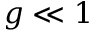Convert formula to latex. <formula><loc_0><loc_0><loc_500><loc_500>g \ll 1</formula> 